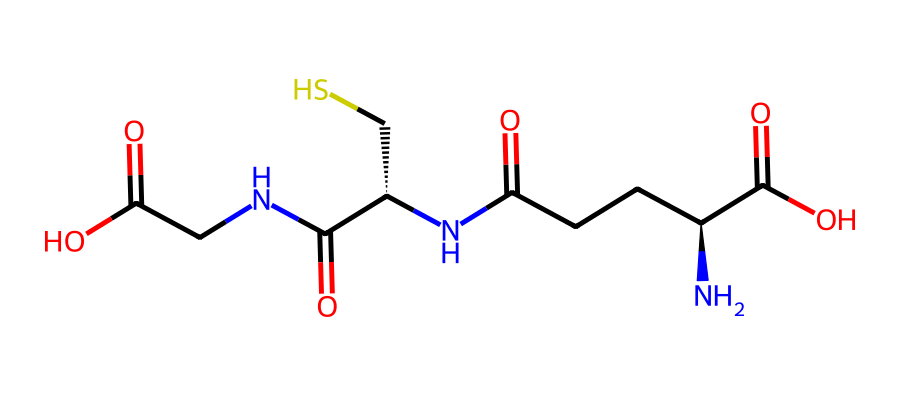What is the molecular formula of glutathione represented by this SMILES? To determine the molecular formula, we need to interpret the SMILES representation, counting the various types of atoms present. The structure contains nitrogen (N), carbon (C), oxygen (O), and sulfur (S) atoms. In the counted atoms, there are 10 carbons, 17 hydrogens, 3 nitrogens, 5 oxygens, and 1 sulfur, leading to the molecular formula C10H17N3O5S.
Answer: C10H17N3O5S How many nitrogen atoms are present in glutathione? By analyzing the SMILES representation, we look for nitrogen (N) symbols. The count shows that there are three nitrogen atoms.
Answer: 3 What type of bond connects the sulfur atom to the carbon in glutathione? In the structural formula represented by the SMILES, the sulfur atom (S) is bonded to a carbon atom (C) through a single bond, which can be inferred from the lack of any double bond symbols or other indicators.
Answer: single bond What role does sulfur play in the structure of glutathione? The sulfur atom in glutathione is part of a thiol group (-SH) that contributes to its antioxidant properties. This functionality allows glutathione to participate in redox reactions, protecting cells from oxidative stress.
Answer: antioxidant property Which functional group is indicated by the presence of the -COOH in glutathione? The presence of -COOH groups indicates carboxylic acid functional groups. In this SMILES representation, we can identify that there are two such groups, which contribute to the molecule's acidic properties and solubility.
Answer: carboxylic acid 